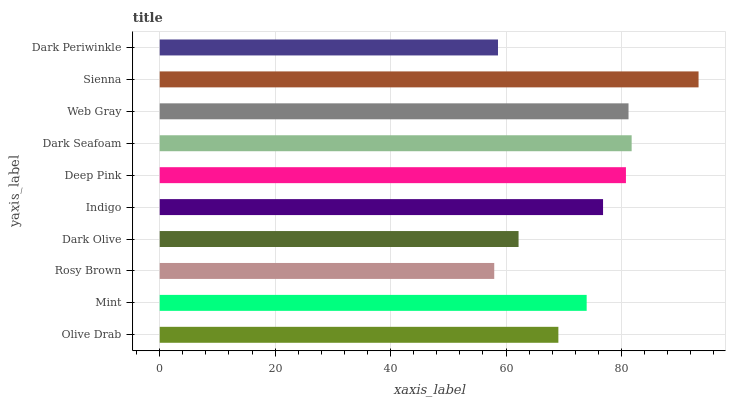Is Rosy Brown the minimum?
Answer yes or no. Yes. Is Sienna the maximum?
Answer yes or no. Yes. Is Mint the minimum?
Answer yes or no. No. Is Mint the maximum?
Answer yes or no. No. Is Mint greater than Olive Drab?
Answer yes or no. Yes. Is Olive Drab less than Mint?
Answer yes or no. Yes. Is Olive Drab greater than Mint?
Answer yes or no. No. Is Mint less than Olive Drab?
Answer yes or no. No. Is Indigo the high median?
Answer yes or no. Yes. Is Mint the low median?
Answer yes or no. Yes. Is Dark Olive the high median?
Answer yes or no. No. Is Dark Olive the low median?
Answer yes or no. No. 